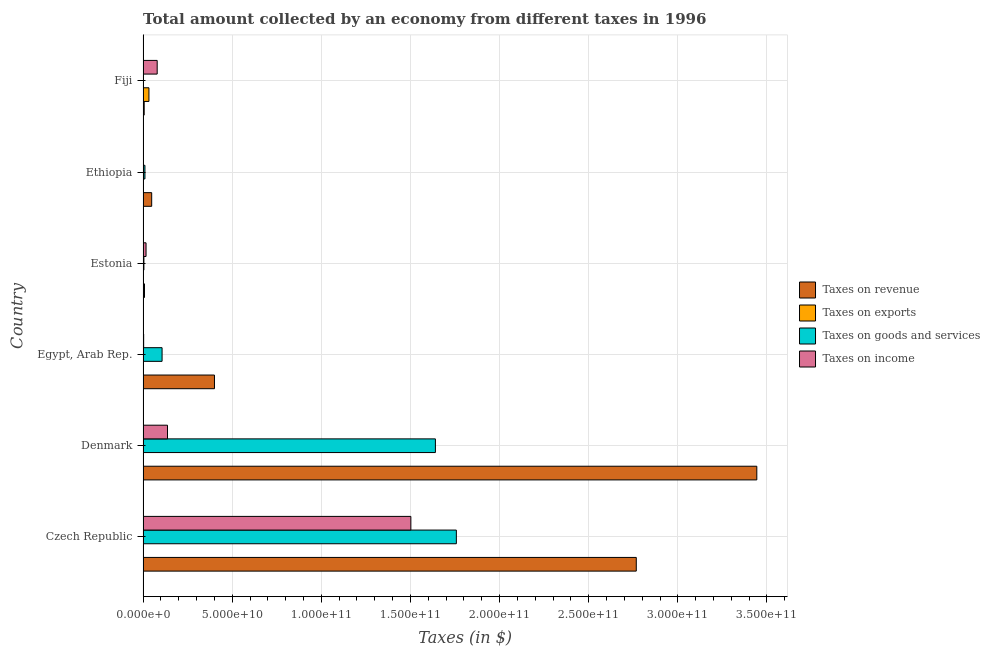How many different coloured bars are there?
Your answer should be very brief. 4. Are the number of bars on each tick of the Y-axis equal?
Your answer should be very brief. Yes. How many bars are there on the 5th tick from the top?
Provide a short and direct response. 4. What is the label of the 4th group of bars from the top?
Give a very brief answer. Egypt, Arab Rep. In how many cases, is the number of bars for a given country not equal to the number of legend labels?
Provide a short and direct response. 0. What is the amount collected as tax on revenue in Denmark?
Provide a short and direct response. 3.44e+11. Across all countries, what is the maximum amount collected as tax on exports?
Provide a short and direct response. 3.29e+09. Across all countries, what is the minimum amount collected as tax on revenue?
Provide a short and direct response. 6.34e+08. In which country was the amount collected as tax on goods maximum?
Make the answer very short. Czech Republic. In which country was the amount collected as tax on exports minimum?
Your response must be concise. Ethiopia. What is the total amount collected as tax on revenue in the graph?
Ensure brevity in your answer.  6.67e+11. What is the difference between the amount collected as tax on income in Denmark and that in Egypt, Arab Rep.?
Make the answer very short. 1.34e+1. What is the difference between the amount collected as tax on revenue in Estonia and the amount collected as tax on income in Ethiopia?
Your answer should be very brief. 5.70e+08. What is the average amount collected as tax on income per country?
Offer a very short reply. 2.90e+1. What is the difference between the amount collected as tax on revenue and amount collected as tax on income in Estonia?
Offer a very short reply. -8.70e+08. In how many countries, is the amount collected as tax on exports greater than 340000000000 $?
Give a very brief answer. 0. What is the ratio of the amount collected as tax on income in Egypt, Arab Rep. to that in Fiji?
Make the answer very short. 0.04. Is the amount collected as tax on income in Denmark less than that in Egypt, Arab Rep.?
Make the answer very short. No. Is the difference between the amount collected as tax on exports in Denmark and Egypt, Arab Rep. greater than the difference between the amount collected as tax on income in Denmark and Egypt, Arab Rep.?
Ensure brevity in your answer.  No. What is the difference between the highest and the second highest amount collected as tax on exports?
Make the answer very short. 3.13e+09. What is the difference between the highest and the lowest amount collected as tax on revenue?
Make the answer very short. 3.44e+11. In how many countries, is the amount collected as tax on income greater than the average amount collected as tax on income taken over all countries?
Give a very brief answer. 1. Is the sum of the amount collected as tax on exports in Egypt, Arab Rep. and Estonia greater than the maximum amount collected as tax on income across all countries?
Keep it short and to the point. No. What does the 1st bar from the top in Estonia represents?
Provide a short and direct response. Taxes on income. What does the 4th bar from the bottom in Egypt, Arab Rep. represents?
Your answer should be compact. Taxes on income. How many bars are there?
Provide a succinct answer. 24. Are all the bars in the graph horizontal?
Offer a very short reply. Yes. How many countries are there in the graph?
Ensure brevity in your answer.  6. Are the values on the major ticks of X-axis written in scientific E-notation?
Offer a very short reply. Yes. Does the graph contain any zero values?
Provide a succinct answer. No. How are the legend labels stacked?
Provide a short and direct response. Vertical. What is the title of the graph?
Offer a terse response. Total amount collected by an economy from different taxes in 1996. What is the label or title of the X-axis?
Ensure brevity in your answer.  Taxes (in $). What is the Taxes (in $) in Taxes on revenue in Czech Republic?
Ensure brevity in your answer.  2.77e+11. What is the Taxes (in $) in Taxes on exports in Czech Republic?
Your answer should be very brief. 1.50e+08. What is the Taxes (in $) of Taxes on goods and services in Czech Republic?
Your answer should be compact. 1.76e+11. What is the Taxes (in $) in Taxes on income in Czech Republic?
Ensure brevity in your answer.  1.50e+11. What is the Taxes (in $) of Taxes on revenue in Denmark?
Your answer should be compact. 3.44e+11. What is the Taxes (in $) in Taxes on exports in Denmark?
Your answer should be very brief. 9.40e+06. What is the Taxes (in $) in Taxes on goods and services in Denmark?
Offer a very short reply. 1.64e+11. What is the Taxes (in $) of Taxes on income in Denmark?
Offer a terse response. 1.37e+1. What is the Taxes (in $) in Taxes on revenue in Egypt, Arab Rep.?
Offer a terse response. 4.01e+1. What is the Taxes (in $) of Taxes on exports in Egypt, Arab Rep.?
Your response must be concise. 1.57e+08. What is the Taxes (in $) of Taxes on goods and services in Egypt, Arab Rep.?
Provide a succinct answer. 1.07e+1. What is the Taxes (in $) in Taxes on income in Egypt, Arab Rep.?
Offer a terse response. 3.35e+08. What is the Taxes (in $) in Taxes on revenue in Estonia?
Ensure brevity in your answer.  8.06e+08. What is the Taxes (in $) in Taxes on goods and services in Estonia?
Make the answer very short. 4.71e+08. What is the Taxes (in $) in Taxes on income in Estonia?
Make the answer very short. 1.68e+09. What is the Taxes (in $) of Taxes on revenue in Ethiopia?
Provide a succinct answer. 4.84e+09. What is the Taxes (in $) in Taxes on exports in Ethiopia?
Offer a terse response. 1.00e+06. What is the Taxes (in $) in Taxes on goods and services in Ethiopia?
Your answer should be compact. 1.05e+09. What is the Taxes (in $) of Taxes on income in Ethiopia?
Give a very brief answer. 2.36e+08. What is the Taxes (in $) of Taxes on revenue in Fiji?
Give a very brief answer. 6.34e+08. What is the Taxes (in $) of Taxes on exports in Fiji?
Your answer should be very brief. 3.29e+09. What is the Taxes (in $) in Taxes on goods and services in Fiji?
Your response must be concise. 2.38e+08. What is the Taxes (in $) in Taxes on income in Fiji?
Make the answer very short. 7.92e+09. Across all countries, what is the maximum Taxes (in $) in Taxes on revenue?
Keep it short and to the point. 3.44e+11. Across all countries, what is the maximum Taxes (in $) in Taxes on exports?
Keep it short and to the point. 3.29e+09. Across all countries, what is the maximum Taxes (in $) of Taxes on goods and services?
Provide a succinct answer. 1.76e+11. Across all countries, what is the maximum Taxes (in $) in Taxes on income?
Offer a terse response. 1.50e+11. Across all countries, what is the minimum Taxes (in $) in Taxes on revenue?
Offer a terse response. 6.34e+08. Across all countries, what is the minimum Taxes (in $) of Taxes on goods and services?
Your answer should be compact. 2.38e+08. Across all countries, what is the minimum Taxes (in $) in Taxes on income?
Keep it short and to the point. 2.36e+08. What is the total Taxes (in $) of Taxes on revenue in the graph?
Offer a very short reply. 6.67e+11. What is the total Taxes (in $) of Taxes on exports in the graph?
Keep it short and to the point. 3.61e+09. What is the total Taxes (in $) of Taxes on goods and services in the graph?
Ensure brevity in your answer.  3.52e+11. What is the total Taxes (in $) in Taxes on income in the graph?
Keep it short and to the point. 1.74e+11. What is the difference between the Taxes (in $) in Taxes on revenue in Czech Republic and that in Denmark?
Give a very brief answer. -6.76e+1. What is the difference between the Taxes (in $) in Taxes on exports in Czech Republic and that in Denmark?
Keep it short and to the point. 1.41e+08. What is the difference between the Taxes (in $) of Taxes on goods and services in Czech Republic and that in Denmark?
Your answer should be very brief. 1.18e+1. What is the difference between the Taxes (in $) in Taxes on income in Czech Republic and that in Denmark?
Provide a short and direct response. 1.37e+11. What is the difference between the Taxes (in $) in Taxes on revenue in Czech Republic and that in Egypt, Arab Rep.?
Give a very brief answer. 2.37e+11. What is the difference between the Taxes (in $) in Taxes on exports in Czech Republic and that in Egypt, Arab Rep.?
Offer a very short reply. -7.19e+06. What is the difference between the Taxes (in $) of Taxes on goods and services in Czech Republic and that in Egypt, Arab Rep.?
Provide a short and direct response. 1.65e+11. What is the difference between the Taxes (in $) in Taxes on income in Czech Republic and that in Egypt, Arab Rep.?
Offer a very short reply. 1.50e+11. What is the difference between the Taxes (in $) in Taxes on revenue in Czech Republic and that in Estonia?
Ensure brevity in your answer.  2.76e+11. What is the difference between the Taxes (in $) in Taxes on exports in Czech Republic and that in Estonia?
Provide a short and direct response. 1.45e+08. What is the difference between the Taxes (in $) of Taxes on goods and services in Czech Republic and that in Estonia?
Keep it short and to the point. 1.75e+11. What is the difference between the Taxes (in $) of Taxes on income in Czech Republic and that in Estonia?
Your answer should be very brief. 1.49e+11. What is the difference between the Taxes (in $) of Taxes on revenue in Czech Republic and that in Ethiopia?
Offer a very short reply. 2.72e+11. What is the difference between the Taxes (in $) in Taxes on exports in Czech Republic and that in Ethiopia?
Your answer should be compact. 1.49e+08. What is the difference between the Taxes (in $) in Taxes on goods and services in Czech Republic and that in Ethiopia?
Keep it short and to the point. 1.75e+11. What is the difference between the Taxes (in $) of Taxes on income in Czech Republic and that in Ethiopia?
Your response must be concise. 1.50e+11. What is the difference between the Taxes (in $) in Taxes on revenue in Czech Republic and that in Fiji?
Offer a terse response. 2.76e+11. What is the difference between the Taxes (in $) in Taxes on exports in Czech Republic and that in Fiji?
Your answer should be compact. -3.14e+09. What is the difference between the Taxes (in $) of Taxes on goods and services in Czech Republic and that in Fiji?
Give a very brief answer. 1.76e+11. What is the difference between the Taxes (in $) in Taxes on income in Czech Republic and that in Fiji?
Offer a very short reply. 1.42e+11. What is the difference between the Taxes (in $) of Taxes on revenue in Denmark and that in Egypt, Arab Rep.?
Give a very brief answer. 3.04e+11. What is the difference between the Taxes (in $) of Taxes on exports in Denmark and that in Egypt, Arab Rep.?
Make the answer very short. -1.48e+08. What is the difference between the Taxes (in $) in Taxes on goods and services in Denmark and that in Egypt, Arab Rep.?
Provide a succinct answer. 1.53e+11. What is the difference between the Taxes (in $) in Taxes on income in Denmark and that in Egypt, Arab Rep.?
Make the answer very short. 1.34e+1. What is the difference between the Taxes (in $) of Taxes on revenue in Denmark and that in Estonia?
Ensure brevity in your answer.  3.43e+11. What is the difference between the Taxes (in $) in Taxes on exports in Denmark and that in Estonia?
Offer a terse response. 4.40e+06. What is the difference between the Taxes (in $) in Taxes on goods and services in Denmark and that in Estonia?
Your answer should be very brief. 1.64e+11. What is the difference between the Taxes (in $) in Taxes on income in Denmark and that in Estonia?
Make the answer very short. 1.20e+1. What is the difference between the Taxes (in $) of Taxes on revenue in Denmark and that in Ethiopia?
Make the answer very short. 3.39e+11. What is the difference between the Taxes (in $) of Taxes on exports in Denmark and that in Ethiopia?
Offer a very short reply. 8.40e+06. What is the difference between the Taxes (in $) in Taxes on goods and services in Denmark and that in Ethiopia?
Offer a terse response. 1.63e+11. What is the difference between the Taxes (in $) of Taxes on income in Denmark and that in Ethiopia?
Provide a short and direct response. 1.35e+1. What is the difference between the Taxes (in $) in Taxes on revenue in Denmark and that in Fiji?
Your answer should be compact. 3.44e+11. What is the difference between the Taxes (in $) of Taxes on exports in Denmark and that in Fiji?
Give a very brief answer. -3.28e+09. What is the difference between the Taxes (in $) in Taxes on goods and services in Denmark and that in Fiji?
Keep it short and to the point. 1.64e+11. What is the difference between the Taxes (in $) of Taxes on income in Denmark and that in Fiji?
Offer a very short reply. 5.78e+09. What is the difference between the Taxes (in $) of Taxes on revenue in Egypt, Arab Rep. and that in Estonia?
Offer a terse response. 3.93e+1. What is the difference between the Taxes (in $) in Taxes on exports in Egypt, Arab Rep. and that in Estonia?
Offer a very short reply. 1.52e+08. What is the difference between the Taxes (in $) of Taxes on goods and services in Egypt, Arab Rep. and that in Estonia?
Ensure brevity in your answer.  1.02e+1. What is the difference between the Taxes (in $) in Taxes on income in Egypt, Arab Rep. and that in Estonia?
Your answer should be very brief. -1.34e+09. What is the difference between the Taxes (in $) in Taxes on revenue in Egypt, Arab Rep. and that in Ethiopia?
Make the answer very short. 3.52e+1. What is the difference between the Taxes (in $) in Taxes on exports in Egypt, Arab Rep. and that in Ethiopia?
Ensure brevity in your answer.  1.56e+08. What is the difference between the Taxes (in $) of Taxes on goods and services in Egypt, Arab Rep. and that in Ethiopia?
Provide a succinct answer. 9.61e+09. What is the difference between the Taxes (in $) of Taxes on income in Egypt, Arab Rep. and that in Ethiopia?
Keep it short and to the point. 9.89e+07. What is the difference between the Taxes (in $) of Taxes on revenue in Egypt, Arab Rep. and that in Fiji?
Your answer should be very brief. 3.94e+1. What is the difference between the Taxes (in $) in Taxes on exports in Egypt, Arab Rep. and that in Fiji?
Your answer should be compact. -3.13e+09. What is the difference between the Taxes (in $) of Taxes on goods and services in Egypt, Arab Rep. and that in Fiji?
Give a very brief answer. 1.04e+1. What is the difference between the Taxes (in $) of Taxes on income in Egypt, Arab Rep. and that in Fiji?
Your answer should be very brief. -7.59e+09. What is the difference between the Taxes (in $) in Taxes on revenue in Estonia and that in Ethiopia?
Ensure brevity in your answer.  -4.03e+09. What is the difference between the Taxes (in $) of Taxes on exports in Estonia and that in Ethiopia?
Your answer should be compact. 4.00e+06. What is the difference between the Taxes (in $) of Taxes on goods and services in Estonia and that in Ethiopia?
Your answer should be very brief. -5.82e+08. What is the difference between the Taxes (in $) in Taxes on income in Estonia and that in Ethiopia?
Ensure brevity in your answer.  1.44e+09. What is the difference between the Taxes (in $) in Taxes on revenue in Estonia and that in Fiji?
Provide a succinct answer. 1.73e+08. What is the difference between the Taxes (in $) in Taxes on exports in Estonia and that in Fiji?
Make the answer very short. -3.29e+09. What is the difference between the Taxes (in $) of Taxes on goods and services in Estonia and that in Fiji?
Ensure brevity in your answer.  2.33e+08. What is the difference between the Taxes (in $) in Taxes on income in Estonia and that in Fiji?
Offer a terse response. -6.25e+09. What is the difference between the Taxes (in $) in Taxes on revenue in Ethiopia and that in Fiji?
Your response must be concise. 4.20e+09. What is the difference between the Taxes (in $) in Taxes on exports in Ethiopia and that in Fiji?
Your response must be concise. -3.29e+09. What is the difference between the Taxes (in $) of Taxes on goods and services in Ethiopia and that in Fiji?
Keep it short and to the point. 8.14e+08. What is the difference between the Taxes (in $) in Taxes on income in Ethiopia and that in Fiji?
Your response must be concise. -7.69e+09. What is the difference between the Taxes (in $) of Taxes on revenue in Czech Republic and the Taxes (in $) of Taxes on exports in Denmark?
Make the answer very short. 2.77e+11. What is the difference between the Taxes (in $) of Taxes on revenue in Czech Republic and the Taxes (in $) of Taxes on goods and services in Denmark?
Keep it short and to the point. 1.13e+11. What is the difference between the Taxes (in $) of Taxes on revenue in Czech Republic and the Taxes (in $) of Taxes on income in Denmark?
Keep it short and to the point. 2.63e+11. What is the difference between the Taxes (in $) in Taxes on exports in Czech Republic and the Taxes (in $) in Taxes on goods and services in Denmark?
Ensure brevity in your answer.  -1.64e+11. What is the difference between the Taxes (in $) in Taxes on exports in Czech Republic and the Taxes (in $) in Taxes on income in Denmark?
Give a very brief answer. -1.36e+1. What is the difference between the Taxes (in $) in Taxes on goods and services in Czech Republic and the Taxes (in $) in Taxes on income in Denmark?
Ensure brevity in your answer.  1.62e+11. What is the difference between the Taxes (in $) of Taxes on revenue in Czech Republic and the Taxes (in $) of Taxes on exports in Egypt, Arab Rep.?
Give a very brief answer. 2.77e+11. What is the difference between the Taxes (in $) in Taxes on revenue in Czech Republic and the Taxes (in $) in Taxes on goods and services in Egypt, Arab Rep.?
Your response must be concise. 2.66e+11. What is the difference between the Taxes (in $) in Taxes on revenue in Czech Republic and the Taxes (in $) in Taxes on income in Egypt, Arab Rep.?
Keep it short and to the point. 2.76e+11. What is the difference between the Taxes (in $) in Taxes on exports in Czech Republic and the Taxes (in $) in Taxes on goods and services in Egypt, Arab Rep.?
Provide a succinct answer. -1.05e+1. What is the difference between the Taxes (in $) in Taxes on exports in Czech Republic and the Taxes (in $) in Taxes on income in Egypt, Arab Rep.?
Give a very brief answer. -1.85e+08. What is the difference between the Taxes (in $) in Taxes on goods and services in Czech Republic and the Taxes (in $) in Taxes on income in Egypt, Arab Rep.?
Make the answer very short. 1.75e+11. What is the difference between the Taxes (in $) in Taxes on revenue in Czech Republic and the Taxes (in $) in Taxes on exports in Estonia?
Offer a terse response. 2.77e+11. What is the difference between the Taxes (in $) of Taxes on revenue in Czech Republic and the Taxes (in $) of Taxes on goods and services in Estonia?
Keep it short and to the point. 2.76e+11. What is the difference between the Taxes (in $) of Taxes on revenue in Czech Republic and the Taxes (in $) of Taxes on income in Estonia?
Your answer should be compact. 2.75e+11. What is the difference between the Taxes (in $) of Taxes on exports in Czech Republic and the Taxes (in $) of Taxes on goods and services in Estonia?
Keep it short and to the point. -3.21e+08. What is the difference between the Taxes (in $) in Taxes on exports in Czech Republic and the Taxes (in $) in Taxes on income in Estonia?
Give a very brief answer. -1.53e+09. What is the difference between the Taxes (in $) of Taxes on goods and services in Czech Republic and the Taxes (in $) of Taxes on income in Estonia?
Your answer should be very brief. 1.74e+11. What is the difference between the Taxes (in $) of Taxes on revenue in Czech Republic and the Taxes (in $) of Taxes on exports in Ethiopia?
Your answer should be very brief. 2.77e+11. What is the difference between the Taxes (in $) of Taxes on revenue in Czech Republic and the Taxes (in $) of Taxes on goods and services in Ethiopia?
Offer a very short reply. 2.76e+11. What is the difference between the Taxes (in $) in Taxes on revenue in Czech Republic and the Taxes (in $) in Taxes on income in Ethiopia?
Provide a succinct answer. 2.76e+11. What is the difference between the Taxes (in $) of Taxes on exports in Czech Republic and the Taxes (in $) of Taxes on goods and services in Ethiopia?
Keep it short and to the point. -9.03e+08. What is the difference between the Taxes (in $) in Taxes on exports in Czech Republic and the Taxes (in $) in Taxes on income in Ethiopia?
Offer a terse response. -8.63e+07. What is the difference between the Taxes (in $) in Taxes on goods and services in Czech Republic and the Taxes (in $) in Taxes on income in Ethiopia?
Provide a succinct answer. 1.76e+11. What is the difference between the Taxes (in $) in Taxes on revenue in Czech Republic and the Taxes (in $) in Taxes on exports in Fiji?
Keep it short and to the point. 2.73e+11. What is the difference between the Taxes (in $) in Taxes on revenue in Czech Republic and the Taxes (in $) in Taxes on goods and services in Fiji?
Give a very brief answer. 2.76e+11. What is the difference between the Taxes (in $) of Taxes on revenue in Czech Republic and the Taxes (in $) of Taxes on income in Fiji?
Provide a short and direct response. 2.69e+11. What is the difference between the Taxes (in $) of Taxes on exports in Czech Republic and the Taxes (in $) of Taxes on goods and services in Fiji?
Your answer should be compact. -8.82e+07. What is the difference between the Taxes (in $) of Taxes on exports in Czech Republic and the Taxes (in $) of Taxes on income in Fiji?
Keep it short and to the point. -7.77e+09. What is the difference between the Taxes (in $) in Taxes on goods and services in Czech Republic and the Taxes (in $) in Taxes on income in Fiji?
Make the answer very short. 1.68e+11. What is the difference between the Taxes (in $) in Taxes on revenue in Denmark and the Taxes (in $) in Taxes on exports in Egypt, Arab Rep.?
Give a very brief answer. 3.44e+11. What is the difference between the Taxes (in $) of Taxes on revenue in Denmark and the Taxes (in $) of Taxes on goods and services in Egypt, Arab Rep.?
Your answer should be compact. 3.34e+11. What is the difference between the Taxes (in $) of Taxes on revenue in Denmark and the Taxes (in $) of Taxes on income in Egypt, Arab Rep.?
Your response must be concise. 3.44e+11. What is the difference between the Taxes (in $) in Taxes on exports in Denmark and the Taxes (in $) in Taxes on goods and services in Egypt, Arab Rep.?
Offer a very short reply. -1.07e+1. What is the difference between the Taxes (in $) of Taxes on exports in Denmark and the Taxes (in $) of Taxes on income in Egypt, Arab Rep.?
Your response must be concise. -3.26e+08. What is the difference between the Taxes (in $) of Taxes on goods and services in Denmark and the Taxes (in $) of Taxes on income in Egypt, Arab Rep.?
Provide a succinct answer. 1.64e+11. What is the difference between the Taxes (in $) in Taxes on revenue in Denmark and the Taxes (in $) in Taxes on exports in Estonia?
Your response must be concise. 3.44e+11. What is the difference between the Taxes (in $) of Taxes on revenue in Denmark and the Taxes (in $) of Taxes on goods and services in Estonia?
Your answer should be very brief. 3.44e+11. What is the difference between the Taxes (in $) in Taxes on revenue in Denmark and the Taxes (in $) in Taxes on income in Estonia?
Your answer should be compact. 3.43e+11. What is the difference between the Taxes (in $) of Taxes on exports in Denmark and the Taxes (in $) of Taxes on goods and services in Estonia?
Keep it short and to the point. -4.61e+08. What is the difference between the Taxes (in $) in Taxes on exports in Denmark and the Taxes (in $) in Taxes on income in Estonia?
Offer a terse response. -1.67e+09. What is the difference between the Taxes (in $) of Taxes on goods and services in Denmark and the Taxes (in $) of Taxes on income in Estonia?
Offer a terse response. 1.62e+11. What is the difference between the Taxes (in $) in Taxes on revenue in Denmark and the Taxes (in $) in Taxes on exports in Ethiopia?
Provide a succinct answer. 3.44e+11. What is the difference between the Taxes (in $) of Taxes on revenue in Denmark and the Taxes (in $) of Taxes on goods and services in Ethiopia?
Provide a short and direct response. 3.43e+11. What is the difference between the Taxes (in $) in Taxes on revenue in Denmark and the Taxes (in $) in Taxes on income in Ethiopia?
Keep it short and to the point. 3.44e+11. What is the difference between the Taxes (in $) of Taxes on exports in Denmark and the Taxes (in $) of Taxes on goods and services in Ethiopia?
Keep it short and to the point. -1.04e+09. What is the difference between the Taxes (in $) in Taxes on exports in Denmark and the Taxes (in $) in Taxes on income in Ethiopia?
Ensure brevity in your answer.  -2.27e+08. What is the difference between the Taxes (in $) in Taxes on goods and services in Denmark and the Taxes (in $) in Taxes on income in Ethiopia?
Give a very brief answer. 1.64e+11. What is the difference between the Taxes (in $) of Taxes on revenue in Denmark and the Taxes (in $) of Taxes on exports in Fiji?
Make the answer very short. 3.41e+11. What is the difference between the Taxes (in $) in Taxes on revenue in Denmark and the Taxes (in $) in Taxes on goods and services in Fiji?
Make the answer very short. 3.44e+11. What is the difference between the Taxes (in $) of Taxes on revenue in Denmark and the Taxes (in $) of Taxes on income in Fiji?
Ensure brevity in your answer.  3.36e+11. What is the difference between the Taxes (in $) of Taxes on exports in Denmark and the Taxes (in $) of Taxes on goods and services in Fiji?
Your answer should be compact. -2.29e+08. What is the difference between the Taxes (in $) of Taxes on exports in Denmark and the Taxes (in $) of Taxes on income in Fiji?
Give a very brief answer. -7.92e+09. What is the difference between the Taxes (in $) of Taxes on goods and services in Denmark and the Taxes (in $) of Taxes on income in Fiji?
Offer a very short reply. 1.56e+11. What is the difference between the Taxes (in $) in Taxes on revenue in Egypt, Arab Rep. and the Taxes (in $) in Taxes on exports in Estonia?
Offer a terse response. 4.01e+1. What is the difference between the Taxes (in $) in Taxes on revenue in Egypt, Arab Rep. and the Taxes (in $) in Taxes on goods and services in Estonia?
Your answer should be very brief. 3.96e+1. What is the difference between the Taxes (in $) of Taxes on revenue in Egypt, Arab Rep. and the Taxes (in $) of Taxes on income in Estonia?
Your response must be concise. 3.84e+1. What is the difference between the Taxes (in $) of Taxes on exports in Egypt, Arab Rep. and the Taxes (in $) of Taxes on goods and services in Estonia?
Offer a very short reply. -3.14e+08. What is the difference between the Taxes (in $) in Taxes on exports in Egypt, Arab Rep. and the Taxes (in $) in Taxes on income in Estonia?
Provide a short and direct response. -1.52e+09. What is the difference between the Taxes (in $) in Taxes on goods and services in Egypt, Arab Rep. and the Taxes (in $) in Taxes on income in Estonia?
Offer a very short reply. 8.99e+09. What is the difference between the Taxes (in $) in Taxes on revenue in Egypt, Arab Rep. and the Taxes (in $) in Taxes on exports in Ethiopia?
Your answer should be very brief. 4.01e+1. What is the difference between the Taxes (in $) in Taxes on revenue in Egypt, Arab Rep. and the Taxes (in $) in Taxes on goods and services in Ethiopia?
Your response must be concise. 3.90e+1. What is the difference between the Taxes (in $) in Taxes on revenue in Egypt, Arab Rep. and the Taxes (in $) in Taxes on income in Ethiopia?
Ensure brevity in your answer.  3.98e+1. What is the difference between the Taxes (in $) of Taxes on exports in Egypt, Arab Rep. and the Taxes (in $) of Taxes on goods and services in Ethiopia?
Your answer should be compact. -8.96e+08. What is the difference between the Taxes (in $) of Taxes on exports in Egypt, Arab Rep. and the Taxes (in $) of Taxes on income in Ethiopia?
Provide a succinct answer. -7.91e+07. What is the difference between the Taxes (in $) in Taxes on goods and services in Egypt, Arab Rep. and the Taxes (in $) in Taxes on income in Ethiopia?
Provide a short and direct response. 1.04e+1. What is the difference between the Taxes (in $) in Taxes on revenue in Egypt, Arab Rep. and the Taxes (in $) in Taxes on exports in Fiji?
Make the answer very short. 3.68e+1. What is the difference between the Taxes (in $) of Taxes on revenue in Egypt, Arab Rep. and the Taxes (in $) of Taxes on goods and services in Fiji?
Your answer should be compact. 3.98e+1. What is the difference between the Taxes (in $) in Taxes on revenue in Egypt, Arab Rep. and the Taxes (in $) in Taxes on income in Fiji?
Ensure brevity in your answer.  3.21e+1. What is the difference between the Taxes (in $) in Taxes on exports in Egypt, Arab Rep. and the Taxes (in $) in Taxes on goods and services in Fiji?
Provide a short and direct response. -8.11e+07. What is the difference between the Taxes (in $) in Taxes on exports in Egypt, Arab Rep. and the Taxes (in $) in Taxes on income in Fiji?
Offer a terse response. -7.77e+09. What is the difference between the Taxes (in $) in Taxes on goods and services in Egypt, Arab Rep. and the Taxes (in $) in Taxes on income in Fiji?
Keep it short and to the point. 2.74e+09. What is the difference between the Taxes (in $) in Taxes on revenue in Estonia and the Taxes (in $) in Taxes on exports in Ethiopia?
Your answer should be very brief. 8.05e+08. What is the difference between the Taxes (in $) in Taxes on revenue in Estonia and the Taxes (in $) in Taxes on goods and services in Ethiopia?
Your response must be concise. -2.47e+08. What is the difference between the Taxes (in $) of Taxes on revenue in Estonia and the Taxes (in $) of Taxes on income in Ethiopia?
Ensure brevity in your answer.  5.70e+08. What is the difference between the Taxes (in $) of Taxes on exports in Estonia and the Taxes (in $) of Taxes on goods and services in Ethiopia?
Offer a terse response. -1.05e+09. What is the difference between the Taxes (in $) of Taxes on exports in Estonia and the Taxes (in $) of Taxes on income in Ethiopia?
Provide a short and direct response. -2.31e+08. What is the difference between the Taxes (in $) in Taxes on goods and services in Estonia and the Taxes (in $) in Taxes on income in Ethiopia?
Keep it short and to the point. 2.35e+08. What is the difference between the Taxes (in $) of Taxes on revenue in Estonia and the Taxes (in $) of Taxes on exports in Fiji?
Ensure brevity in your answer.  -2.49e+09. What is the difference between the Taxes (in $) in Taxes on revenue in Estonia and the Taxes (in $) in Taxes on goods and services in Fiji?
Offer a very short reply. 5.68e+08. What is the difference between the Taxes (in $) of Taxes on revenue in Estonia and the Taxes (in $) of Taxes on income in Fiji?
Keep it short and to the point. -7.12e+09. What is the difference between the Taxes (in $) of Taxes on exports in Estonia and the Taxes (in $) of Taxes on goods and services in Fiji?
Ensure brevity in your answer.  -2.33e+08. What is the difference between the Taxes (in $) of Taxes on exports in Estonia and the Taxes (in $) of Taxes on income in Fiji?
Give a very brief answer. -7.92e+09. What is the difference between the Taxes (in $) of Taxes on goods and services in Estonia and the Taxes (in $) of Taxes on income in Fiji?
Your answer should be compact. -7.45e+09. What is the difference between the Taxes (in $) of Taxes on revenue in Ethiopia and the Taxes (in $) of Taxes on exports in Fiji?
Give a very brief answer. 1.54e+09. What is the difference between the Taxes (in $) of Taxes on revenue in Ethiopia and the Taxes (in $) of Taxes on goods and services in Fiji?
Ensure brevity in your answer.  4.60e+09. What is the difference between the Taxes (in $) of Taxes on revenue in Ethiopia and the Taxes (in $) of Taxes on income in Fiji?
Offer a very short reply. -3.09e+09. What is the difference between the Taxes (in $) of Taxes on exports in Ethiopia and the Taxes (in $) of Taxes on goods and services in Fiji?
Provide a short and direct response. -2.37e+08. What is the difference between the Taxes (in $) of Taxes on exports in Ethiopia and the Taxes (in $) of Taxes on income in Fiji?
Ensure brevity in your answer.  -7.92e+09. What is the difference between the Taxes (in $) of Taxes on goods and services in Ethiopia and the Taxes (in $) of Taxes on income in Fiji?
Provide a short and direct response. -6.87e+09. What is the average Taxes (in $) in Taxes on revenue per country?
Your answer should be compact. 1.11e+11. What is the average Taxes (in $) in Taxes on exports per country?
Your answer should be very brief. 6.02e+08. What is the average Taxes (in $) of Taxes on goods and services per country?
Make the answer very short. 5.87e+1. What is the average Taxes (in $) in Taxes on income per country?
Give a very brief answer. 2.90e+1. What is the difference between the Taxes (in $) in Taxes on revenue and Taxes (in $) in Taxes on exports in Czech Republic?
Give a very brief answer. 2.77e+11. What is the difference between the Taxes (in $) in Taxes on revenue and Taxes (in $) in Taxes on goods and services in Czech Republic?
Your answer should be compact. 1.01e+11. What is the difference between the Taxes (in $) in Taxes on revenue and Taxes (in $) in Taxes on income in Czech Republic?
Offer a terse response. 1.26e+11. What is the difference between the Taxes (in $) in Taxes on exports and Taxes (in $) in Taxes on goods and services in Czech Republic?
Keep it short and to the point. -1.76e+11. What is the difference between the Taxes (in $) in Taxes on exports and Taxes (in $) in Taxes on income in Czech Republic?
Provide a succinct answer. -1.50e+11. What is the difference between the Taxes (in $) in Taxes on goods and services and Taxes (in $) in Taxes on income in Czech Republic?
Give a very brief answer. 2.55e+1. What is the difference between the Taxes (in $) in Taxes on revenue and Taxes (in $) in Taxes on exports in Denmark?
Keep it short and to the point. 3.44e+11. What is the difference between the Taxes (in $) of Taxes on revenue and Taxes (in $) of Taxes on goods and services in Denmark?
Keep it short and to the point. 1.80e+11. What is the difference between the Taxes (in $) in Taxes on revenue and Taxes (in $) in Taxes on income in Denmark?
Offer a very short reply. 3.31e+11. What is the difference between the Taxes (in $) of Taxes on exports and Taxes (in $) of Taxes on goods and services in Denmark?
Your response must be concise. -1.64e+11. What is the difference between the Taxes (in $) in Taxes on exports and Taxes (in $) in Taxes on income in Denmark?
Your response must be concise. -1.37e+1. What is the difference between the Taxes (in $) in Taxes on goods and services and Taxes (in $) in Taxes on income in Denmark?
Offer a terse response. 1.50e+11. What is the difference between the Taxes (in $) of Taxes on revenue and Taxes (in $) of Taxes on exports in Egypt, Arab Rep.?
Provide a succinct answer. 3.99e+1. What is the difference between the Taxes (in $) in Taxes on revenue and Taxes (in $) in Taxes on goods and services in Egypt, Arab Rep.?
Provide a short and direct response. 2.94e+1. What is the difference between the Taxes (in $) in Taxes on revenue and Taxes (in $) in Taxes on income in Egypt, Arab Rep.?
Give a very brief answer. 3.97e+1. What is the difference between the Taxes (in $) in Taxes on exports and Taxes (in $) in Taxes on goods and services in Egypt, Arab Rep.?
Keep it short and to the point. -1.05e+1. What is the difference between the Taxes (in $) of Taxes on exports and Taxes (in $) of Taxes on income in Egypt, Arab Rep.?
Provide a succinct answer. -1.78e+08. What is the difference between the Taxes (in $) in Taxes on goods and services and Taxes (in $) in Taxes on income in Egypt, Arab Rep.?
Offer a terse response. 1.03e+1. What is the difference between the Taxes (in $) of Taxes on revenue and Taxes (in $) of Taxes on exports in Estonia?
Your answer should be compact. 8.01e+08. What is the difference between the Taxes (in $) of Taxes on revenue and Taxes (in $) of Taxes on goods and services in Estonia?
Make the answer very short. 3.35e+08. What is the difference between the Taxes (in $) of Taxes on revenue and Taxes (in $) of Taxes on income in Estonia?
Offer a very short reply. -8.70e+08. What is the difference between the Taxes (in $) of Taxes on exports and Taxes (in $) of Taxes on goods and services in Estonia?
Give a very brief answer. -4.66e+08. What is the difference between the Taxes (in $) in Taxes on exports and Taxes (in $) in Taxes on income in Estonia?
Your answer should be very brief. -1.67e+09. What is the difference between the Taxes (in $) of Taxes on goods and services and Taxes (in $) of Taxes on income in Estonia?
Offer a very short reply. -1.21e+09. What is the difference between the Taxes (in $) in Taxes on revenue and Taxes (in $) in Taxes on exports in Ethiopia?
Your answer should be very brief. 4.83e+09. What is the difference between the Taxes (in $) of Taxes on revenue and Taxes (in $) of Taxes on goods and services in Ethiopia?
Your answer should be compact. 3.78e+09. What is the difference between the Taxes (in $) of Taxes on revenue and Taxes (in $) of Taxes on income in Ethiopia?
Your answer should be very brief. 4.60e+09. What is the difference between the Taxes (in $) in Taxes on exports and Taxes (in $) in Taxes on goods and services in Ethiopia?
Ensure brevity in your answer.  -1.05e+09. What is the difference between the Taxes (in $) in Taxes on exports and Taxes (in $) in Taxes on income in Ethiopia?
Your answer should be compact. -2.35e+08. What is the difference between the Taxes (in $) of Taxes on goods and services and Taxes (in $) of Taxes on income in Ethiopia?
Your answer should be compact. 8.16e+08. What is the difference between the Taxes (in $) of Taxes on revenue and Taxes (in $) of Taxes on exports in Fiji?
Provide a succinct answer. -2.66e+09. What is the difference between the Taxes (in $) of Taxes on revenue and Taxes (in $) of Taxes on goods and services in Fiji?
Provide a short and direct response. 3.95e+08. What is the difference between the Taxes (in $) in Taxes on revenue and Taxes (in $) in Taxes on income in Fiji?
Offer a very short reply. -7.29e+09. What is the difference between the Taxes (in $) in Taxes on exports and Taxes (in $) in Taxes on goods and services in Fiji?
Offer a terse response. 3.05e+09. What is the difference between the Taxes (in $) in Taxes on exports and Taxes (in $) in Taxes on income in Fiji?
Your answer should be very brief. -4.63e+09. What is the difference between the Taxes (in $) of Taxes on goods and services and Taxes (in $) of Taxes on income in Fiji?
Your answer should be very brief. -7.69e+09. What is the ratio of the Taxes (in $) in Taxes on revenue in Czech Republic to that in Denmark?
Your response must be concise. 0.8. What is the ratio of the Taxes (in $) in Taxes on exports in Czech Republic to that in Denmark?
Ensure brevity in your answer.  15.96. What is the ratio of the Taxes (in $) in Taxes on goods and services in Czech Republic to that in Denmark?
Ensure brevity in your answer.  1.07. What is the ratio of the Taxes (in $) of Taxes on income in Czech Republic to that in Denmark?
Keep it short and to the point. 10.96. What is the ratio of the Taxes (in $) of Taxes on revenue in Czech Republic to that in Egypt, Arab Rep.?
Keep it short and to the point. 6.91. What is the ratio of the Taxes (in $) of Taxes on exports in Czech Republic to that in Egypt, Arab Rep.?
Your answer should be very brief. 0.95. What is the ratio of the Taxes (in $) in Taxes on goods and services in Czech Republic to that in Egypt, Arab Rep.?
Your response must be concise. 16.48. What is the ratio of the Taxes (in $) of Taxes on income in Czech Republic to that in Egypt, Arab Rep.?
Your answer should be compact. 448.17. What is the ratio of the Taxes (in $) in Taxes on revenue in Czech Republic to that in Estonia?
Your answer should be compact. 343.23. What is the ratio of the Taxes (in $) in Taxes on exports in Czech Republic to that in Estonia?
Your answer should be compact. 30. What is the ratio of the Taxes (in $) in Taxes on goods and services in Czech Republic to that in Estonia?
Your answer should be very brief. 373.27. What is the ratio of the Taxes (in $) of Taxes on income in Czech Republic to that in Estonia?
Your answer should be compact. 89.61. What is the ratio of the Taxes (in $) of Taxes on revenue in Czech Republic to that in Ethiopia?
Offer a very short reply. 57.22. What is the ratio of the Taxes (in $) in Taxes on exports in Czech Republic to that in Ethiopia?
Offer a very short reply. 150. What is the ratio of the Taxes (in $) in Taxes on goods and services in Czech Republic to that in Ethiopia?
Your response must be concise. 166.95. What is the ratio of the Taxes (in $) of Taxes on income in Czech Republic to that in Ethiopia?
Your response must be concise. 635.78. What is the ratio of the Taxes (in $) in Taxes on revenue in Czech Republic to that in Fiji?
Your answer should be very brief. 436.73. What is the ratio of the Taxes (in $) in Taxes on exports in Czech Republic to that in Fiji?
Provide a succinct answer. 0.05. What is the ratio of the Taxes (in $) in Taxes on goods and services in Czech Republic to that in Fiji?
Your answer should be compact. 737.66. What is the ratio of the Taxes (in $) of Taxes on income in Czech Republic to that in Fiji?
Provide a succinct answer. 18.96. What is the ratio of the Taxes (in $) in Taxes on revenue in Denmark to that in Egypt, Arab Rep.?
Give a very brief answer. 8.59. What is the ratio of the Taxes (in $) of Taxes on exports in Denmark to that in Egypt, Arab Rep.?
Keep it short and to the point. 0.06. What is the ratio of the Taxes (in $) in Taxes on goods and services in Denmark to that in Egypt, Arab Rep.?
Offer a terse response. 15.37. What is the ratio of the Taxes (in $) in Taxes on income in Denmark to that in Egypt, Arab Rep.?
Give a very brief answer. 40.89. What is the ratio of the Taxes (in $) in Taxes on revenue in Denmark to that in Estonia?
Your answer should be very brief. 427.12. What is the ratio of the Taxes (in $) of Taxes on exports in Denmark to that in Estonia?
Provide a short and direct response. 1.88. What is the ratio of the Taxes (in $) in Taxes on goods and services in Denmark to that in Estonia?
Offer a very short reply. 348.31. What is the ratio of the Taxes (in $) of Taxes on income in Denmark to that in Estonia?
Provide a succinct answer. 8.18. What is the ratio of the Taxes (in $) in Taxes on revenue in Denmark to that in Ethiopia?
Your answer should be compact. 71.21. What is the ratio of the Taxes (in $) of Taxes on exports in Denmark to that in Ethiopia?
Offer a very short reply. 9.4. What is the ratio of the Taxes (in $) of Taxes on goods and services in Denmark to that in Ethiopia?
Offer a very short reply. 155.78. What is the ratio of the Taxes (in $) of Taxes on income in Denmark to that in Ethiopia?
Your answer should be compact. 58.01. What is the ratio of the Taxes (in $) in Taxes on revenue in Denmark to that in Fiji?
Your answer should be compact. 543.47. What is the ratio of the Taxes (in $) of Taxes on exports in Denmark to that in Fiji?
Your response must be concise. 0. What is the ratio of the Taxes (in $) in Taxes on goods and services in Denmark to that in Fiji?
Offer a very short reply. 688.32. What is the ratio of the Taxes (in $) of Taxes on income in Denmark to that in Fiji?
Provide a short and direct response. 1.73. What is the ratio of the Taxes (in $) in Taxes on revenue in Egypt, Arab Rep. to that in Estonia?
Your answer should be compact. 49.7. What is the ratio of the Taxes (in $) of Taxes on exports in Egypt, Arab Rep. to that in Estonia?
Give a very brief answer. 31.44. What is the ratio of the Taxes (in $) of Taxes on goods and services in Egypt, Arab Rep. to that in Estonia?
Your answer should be compact. 22.66. What is the ratio of the Taxes (in $) of Taxes on income in Egypt, Arab Rep. to that in Estonia?
Ensure brevity in your answer.  0.2. What is the ratio of the Taxes (in $) of Taxes on revenue in Egypt, Arab Rep. to that in Ethiopia?
Ensure brevity in your answer.  8.29. What is the ratio of the Taxes (in $) in Taxes on exports in Egypt, Arab Rep. to that in Ethiopia?
Provide a short and direct response. 157.19. What is the ratio of the Taxes (in $) of Taxes on goods and services in Egypt, Arab Rep. to that in Ethiopia?
Your answer should be very brief. 10.13. What is the ratio of the Taxes (in $) of Taxes on income in Egypt, Arab Rep. to that in Ethiopia?
Give a very brief answer. 1.42. What is the ratio of the Taxes (in $) of Taxes on revenue in Egypt, Arab Rep. to that in Fiji?
Give a very brief answer. 63.23. What is the ratio of the Taxes (in $) of Taxes on exports in Egypt, Arab Rep. to that in Fiji?
Make the answer very short. 0.05. What is the ratio of the Taxes (in $) of Taxes on goods and services in Egypt, Arab Rep. to that in Fiji?
Provide a succinct answer. 44.77. What is the ratio of the Taxes (in $) in Taxes on income in Egypt, Arab Rep. to that in Fiji?
Make the answer very short. 0.04. What is the ratio of the Taxes (in $) of Taxes on goods and services in Estonia to that in Ethiopia?
Ensure brevity in your answer.  0.45. What is the ratio of the Taxes (in $) in Taxes on income in Estonia to that in Ethiopia?
Your answer should be very brief. 7.1. What is the ratio of the Taxes (in $) in Taxes on revenue in Estonia to that in Fiji?
Your response must be concise. 1.27. What is the ratio of the Taxes (in $) in Taxes on exports in Estonia to that in Fiji?
Your answer should be very brief. 0. What is the ratio of the Taxes (in $) in Taxes on goods and services in Estonia to that in Fiji?
Ensure brevity in your answer.  1.98. What is the ratio of the Taxes (in $) in Taxes on income in Estonia to that in Fiji?
Offer a very short reply. 0.21. What is the ratio of the Taxes (in $) of Taxes on revenue in Ethiopia to that in Fiji?
Your answer should be compact. 7.63. What is the ratio of the Taxes (in $) of Taxes on goods and services in Ethiopia to that in Fiji?
Keep it short and to the point. 4.42. What is the ratio of the Taxes (in $) in Taxes on income in Ethiopia to that in Fiji?
Your answer should be very brief. 0.03. What is the difference between the highest and the second highest Taxes (in $) of Taxes on revenue?
Offer a terse response. 6.76e+1. What is the difference between the highest and the second highest Taxes (in $) in Taxes on exports?
Offer a terse response. 3.13e+09. What is the difference between the highest and the second highest Taxes (in $) of Taxes on goods and services?
Keep it short and to the point. 1.18e+1. What is the difference between the highest and the second highest Taxes (in $) in Taxes on income?
Your response must be concise. 1.37e+11. What is the difference between the highest and the lowest Taxes (in $) of Taxes on revenue?
Offer a very short reply. 3.44e+11. What is the difference between the highest and the lowest Taxes (in $) in Taxes on exports?
Keep it short and to the point. 3.29e+09. What is the difference between the highest and the lowest Taxes (in $) of Taxes on goods and services?
Keep it short and to the point. 1.76e+11. What is the difference between the highest and the lowest Taxes (in $) in Taxes on income?
Ensure brevity in your answer.  1.50e+11. 